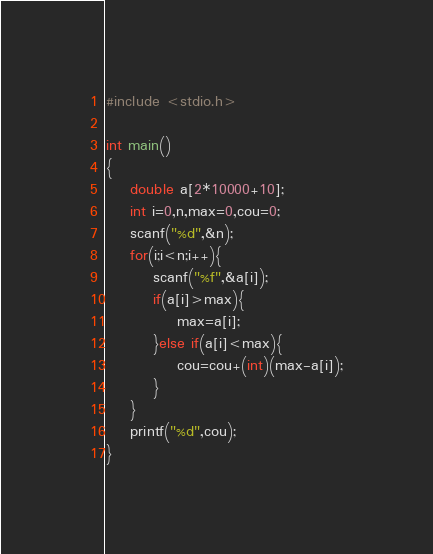Convert code to text. <code><loc_0><loc_0><loc_500><loc_500><_C_>#include <stdio.h>

int main()
{
	double a[2*10000+10];
	int i=0,n,max=0,cou=0;
	scanf("%d",&n);
	for(i;i<n;i++){
		scanf("%f",&a[i]);
		if(a[i]>max){
			max=a[i];
		}else if(a[i]<max){
			cou=cou+(int)(max-a[i]);
		}
	}
	printf("%d",cou);	
}</code> 